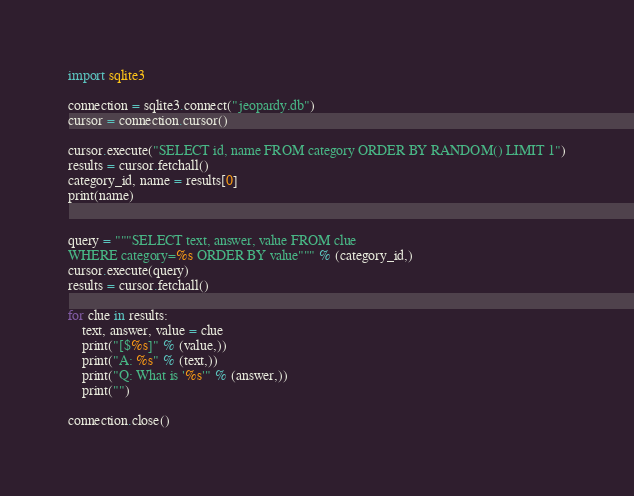Convert code to text. <code><loc_0><loc_0><loc_500><loc_500><_Python_>import sqlite3

connection = sqlite3.connect("jeopardy.db")
cursor = connection.cursor()

cursor.execute("SELECT id, name FROM category ORDER BY RANDOM() LIMIT 1")
results = cursor.fetchall()
category_id, name = results[0]
print(name)


query = """SELECT text, answer, value FROM clue
WHERE category=%s ORDER BY value""" % (category_id,)
cursor.execute(query)
results = cursor.fetchall()

for clue in results:
    text, answer, value = clue
    print("[$%s]" % (value,))
    print("A: %s" % (text,))
    print("Q: What is '%s'" % (answer,))
    print("")

connection.close()
</code> 